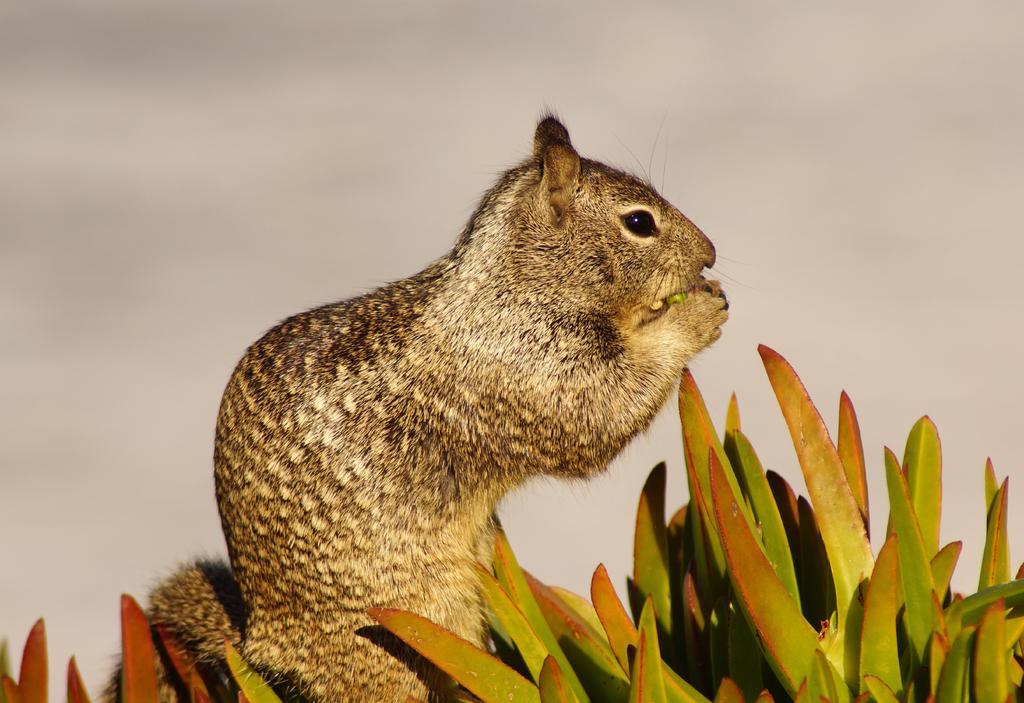What type of animal can be seen in the image? There is a squirrel in the image. What else is present in the image besides the squirrel? There are plants in the image. What type of structure is visible in the image? There is a wall in the image. What type of punishment is the squirrel receiving in the image? There is no indication of punishment in the image; the squirrel is simply present among the plants and wall. 